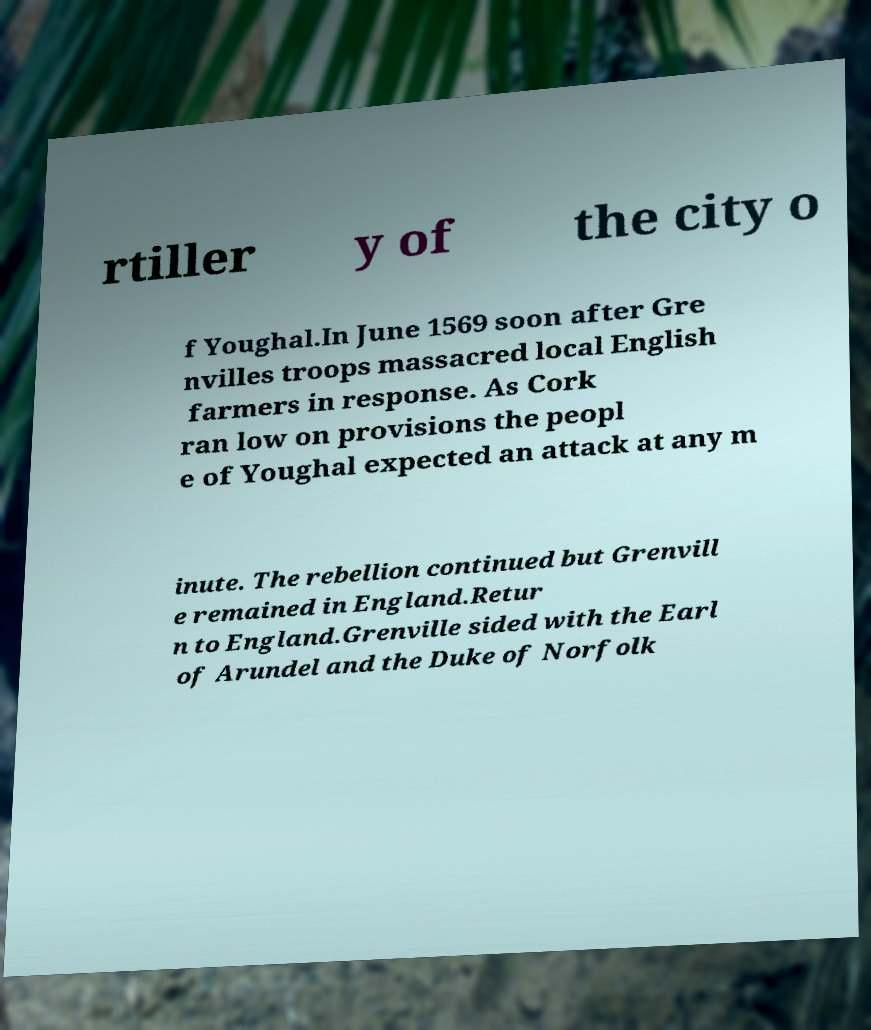Please read and relay the text visible in this image. What does it say? rtiller y of the city o f Youghal.In June 1569 soon after Gre nvilles troops massacred local English farmers in response. As Cork ran low on provisions the peopl e of Youghal expected an attack at any m inute. The rebellion continued but Grenvill e remained in England.Retur n to England.Grenville sided with the Earl of Arundel and the Duke of Norfolk 